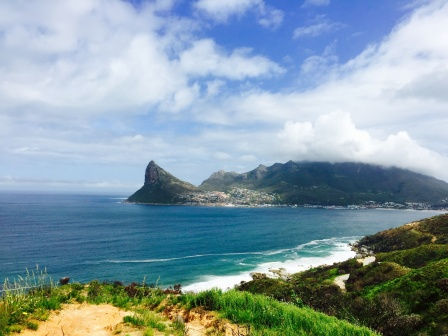If this location were part of a fantasy world, what magical elements could exist here? In a fantasy world, this coastal location could be adorned with an array of magical elements that enhance its natural beauty and mystique. The ocean might be home to merfolk, who navigate the deep blue waters with grace and wisdom, singing hauntingly beautiful songs that echo through the waves. Enchanted dolphins could communicate telepathically with the town’s inhabitants, offering guidance and protection.

The green hills might be dotted with rare, luminescent flowers that glow at night, creating a breathtaking, sparkling landscape under the stars. Ancient, sentient trees could serve as guardians of the forest, sharing their ancient wisdom with those who seek it. The rocky coastline might hide secret entrances to mystical caverns filled with glowing crystals and hidden treasures.

The small town could be inhabited by a harmonious mix of humans, elves, and other fantastical beings, all living together in peace. Magic might be woven into the fabric of everyday life, with artisans crafting enchanted items and healers using magical herbs to cure ailments. At dusk, the sky could transform into a canvas of dazzling colors, as magical fireflies dance in the air, illuminating the night with their soft, warm light.

Overall, this fantasy coastal location would be a place of wonder and enchantment, where the line between the natural and the magical is beautifully blurred, offering endless adventures and discoveries. 